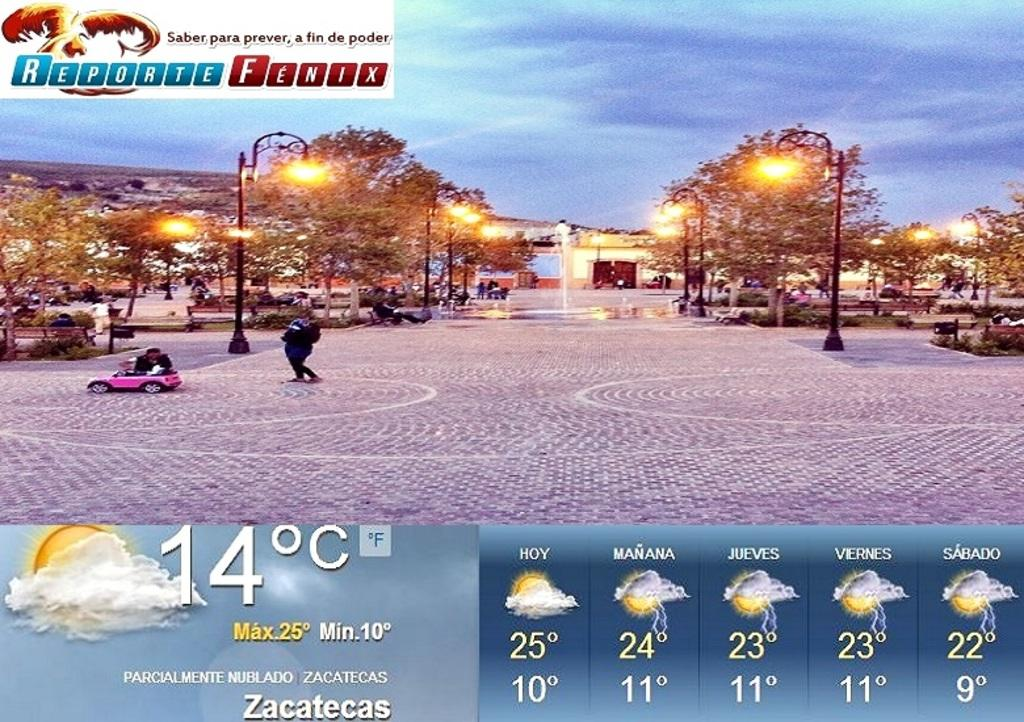<image>
Render a clear and concise summary of the photo. Reporte fenx showing the weather for the entire week 